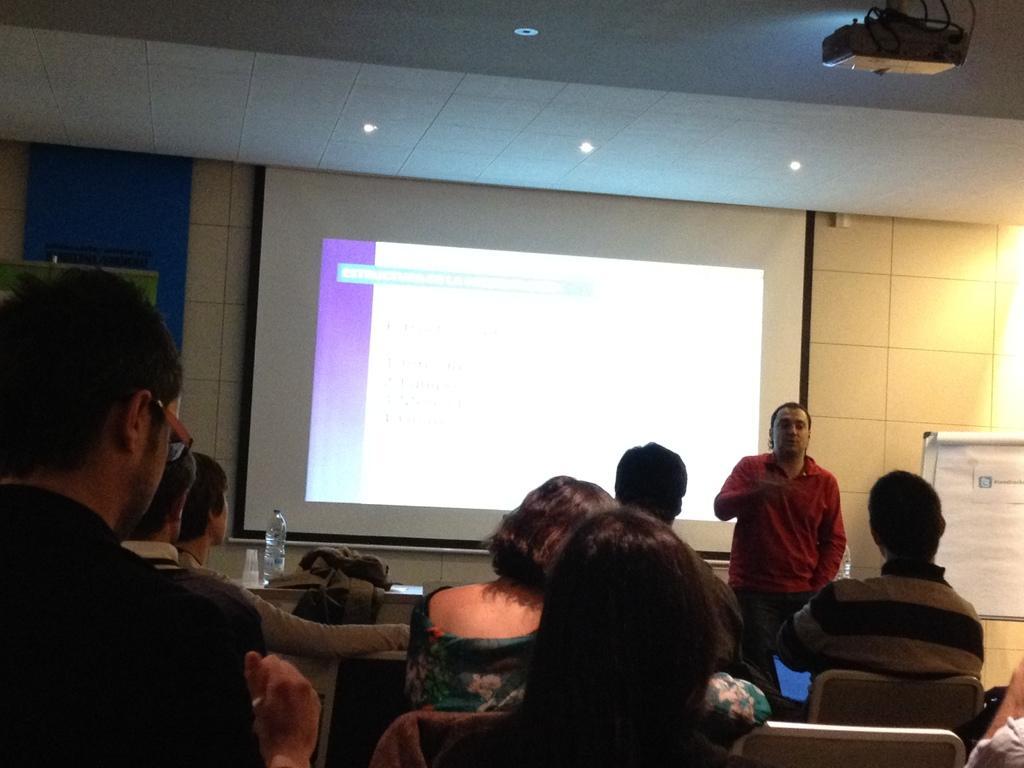Could you give a brief overview of what you see in this image? In the background we can see the screen and the wall. In this picture we can see the ceiling, lights, projector device, objects and board. On paper we can see information. On a table we can see a jacket, bottle, glasses. We can see the people sitting on the chairs. On the right side of the picture we can see a man is standing. 